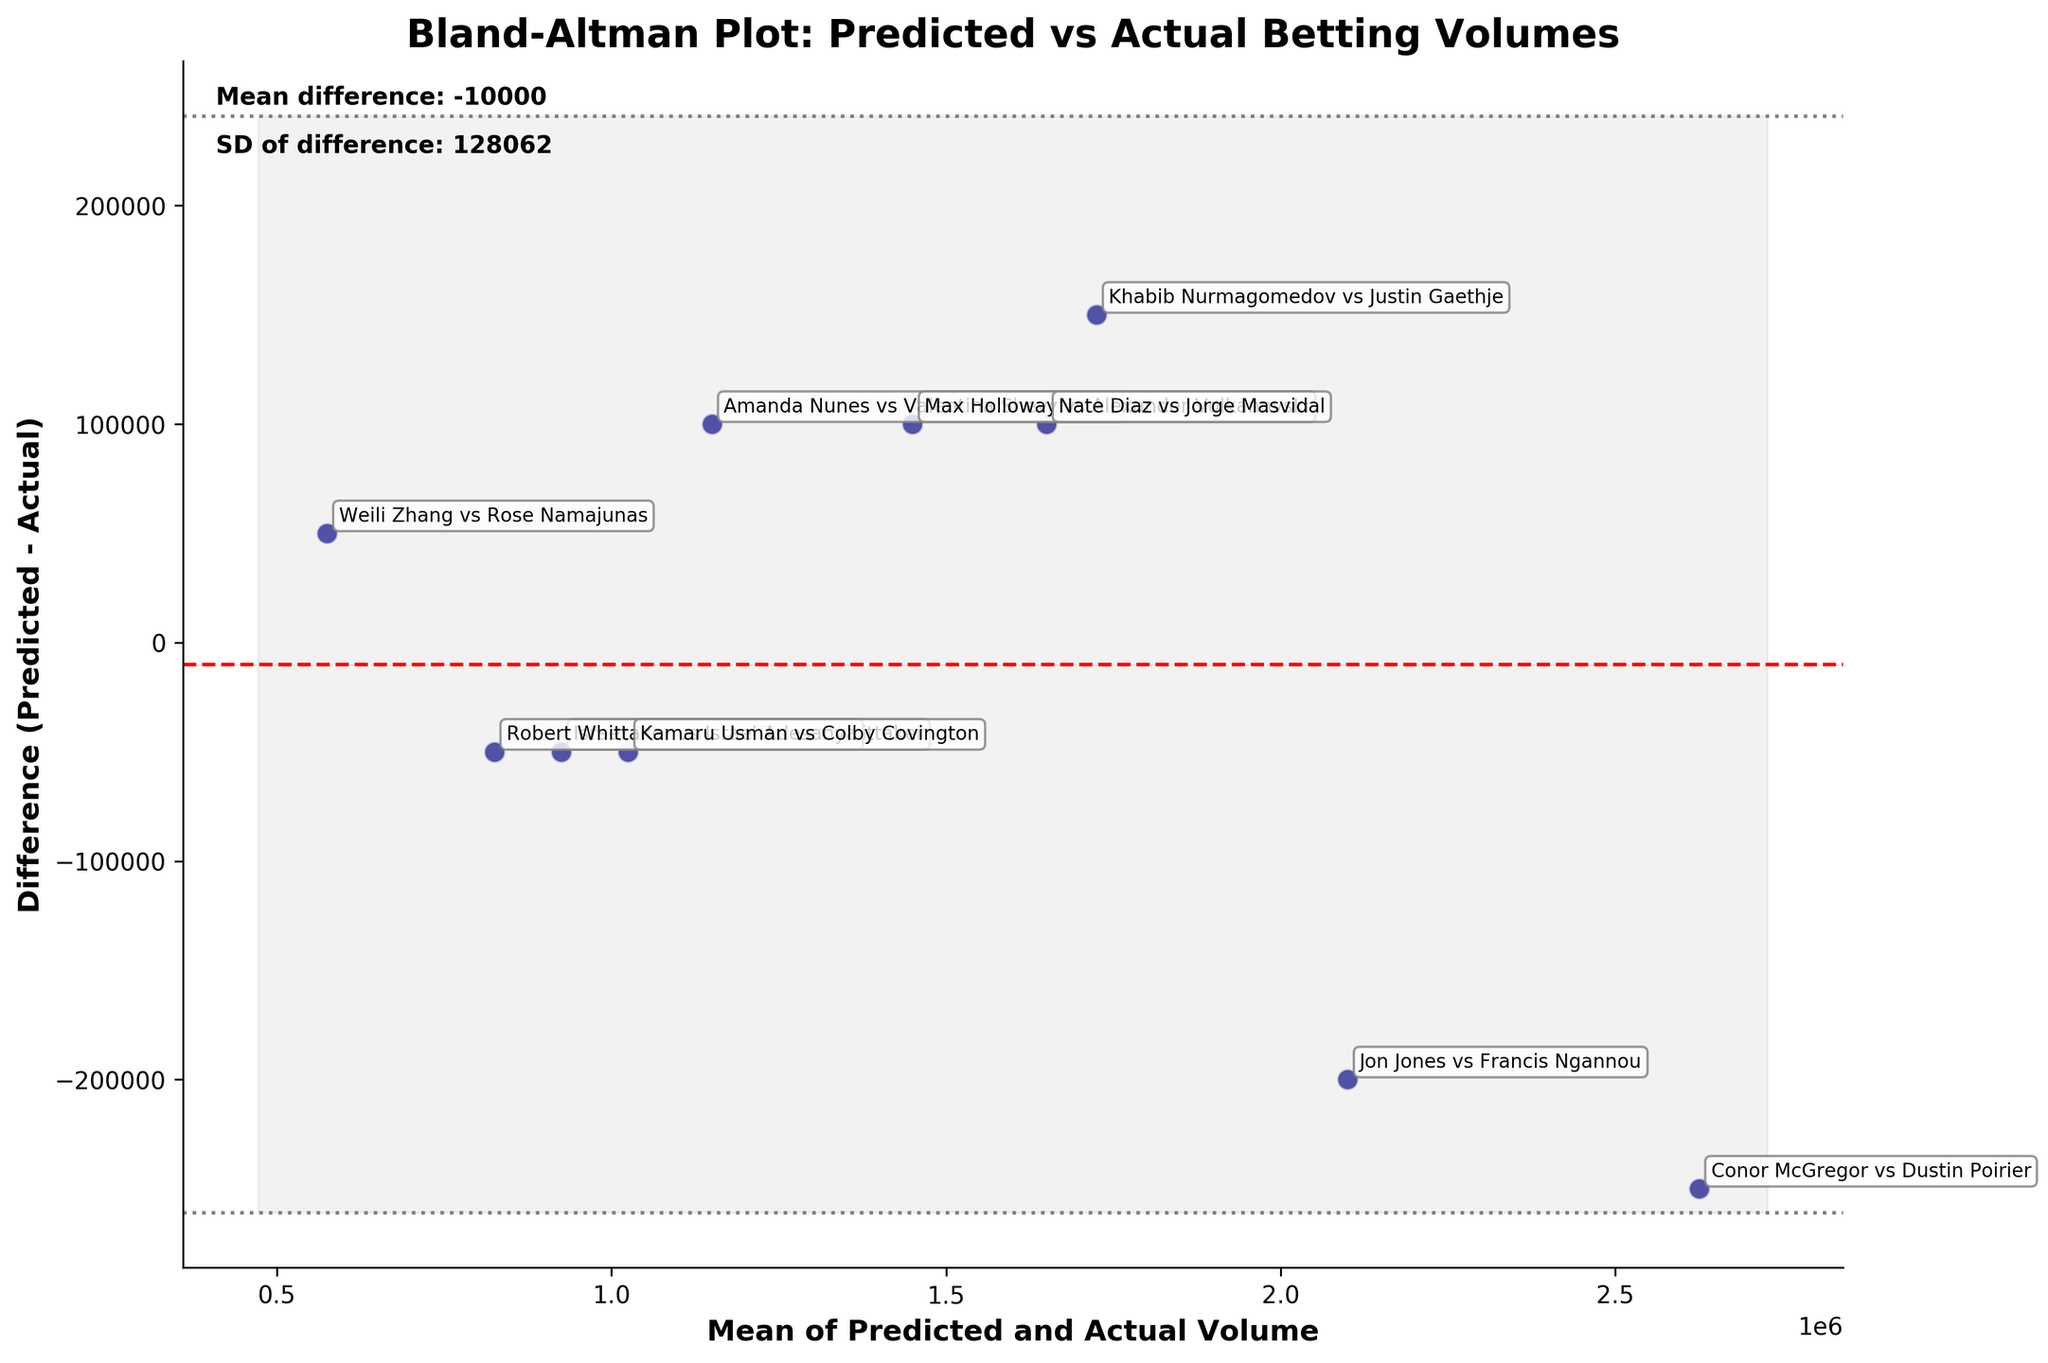What is the title of the plot? The title of the plot is located at the top and reads 'Bland-Altman Plot: Predicted vs Actual Betting Volumes'.
Answer: Bland-Altman Plot: Predicted vs Actual Betting Volumes Which two lines represent the limits of agreement in the plot? The two grey dashed lines represent the limits of agreement, which are calculated as the mean difference plus and minus 1.96 times the standard deviation of the differences.
Answer: The two grey dashed lines What does the red dashed line in the plot signify? The red dashed line represents the mean difference between the predicted and actual betting volumes.
Answer: The mean difference How many high-profile UFC fights are represented in the plot? Each point in the Bland–Altman plot corresponds to one fight. By counting the number of points, we determine there are 10 fights.
Answer: 10 Which fight has the biggest positive difference between predicted and actual betting volumes? By observing the y-axis, the highest point above the mean difference line (red dashed line) indicates the fight with the largest positive difference. The annotation shows this fight is "Jon Jones vs Francis Ngannou".
Answer: Jon Jones vs Francis Ngannou Which region has the point closest to the mean difference line? Finding which fight's point is closest to the red dashed mean difference line, we see that the point for "Kamaru Usman vs Colby Covington" from Africa is nearly on the line.
Answer: Africa What are the mean and standard deviation of the differences? The mean difference and standard deviation are indicated on the plot. The text on the plot mentions "Mean difference: -50000" and "SD of difference: 174284".
Answer: -50000, 174284 What is the range of volumes between which most differences fall? The upper and lower limits of agreement (+/- 1.96 SD) show the range where most differences are expected to fall. The lines and text on the plot show this range as approximately -382656 to 282656.
Answer: -382656 to 282656 Which fight has a predicted volume very close to the actual volume? The point nearest to zero on the y-axis (difference) represents the fight where predicted and actual volumes are closest. This point is closest to "Israel Adesanya vs Robert Whittaker".
Answer: Israel Adesanya vs Robert Whittaker 